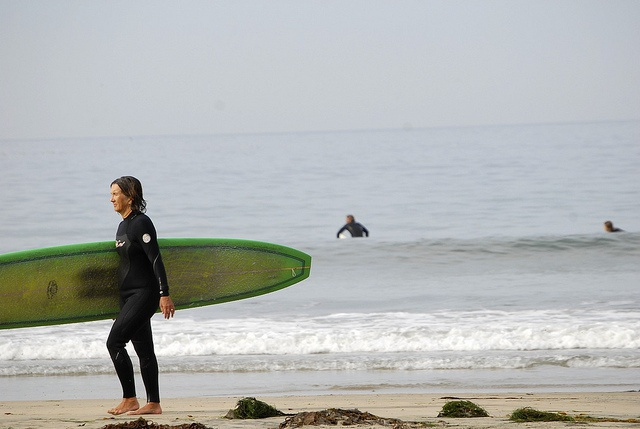Describe the objects in this image and their specific colors. I can see surfboard in darkgray, darkgreen, and black tones, people in darkgray, black, lightgray, brown, and gray tones, people in darkgray, black, and gray tones, and people in darkgray, gray, black, and maroon tones in this image. 